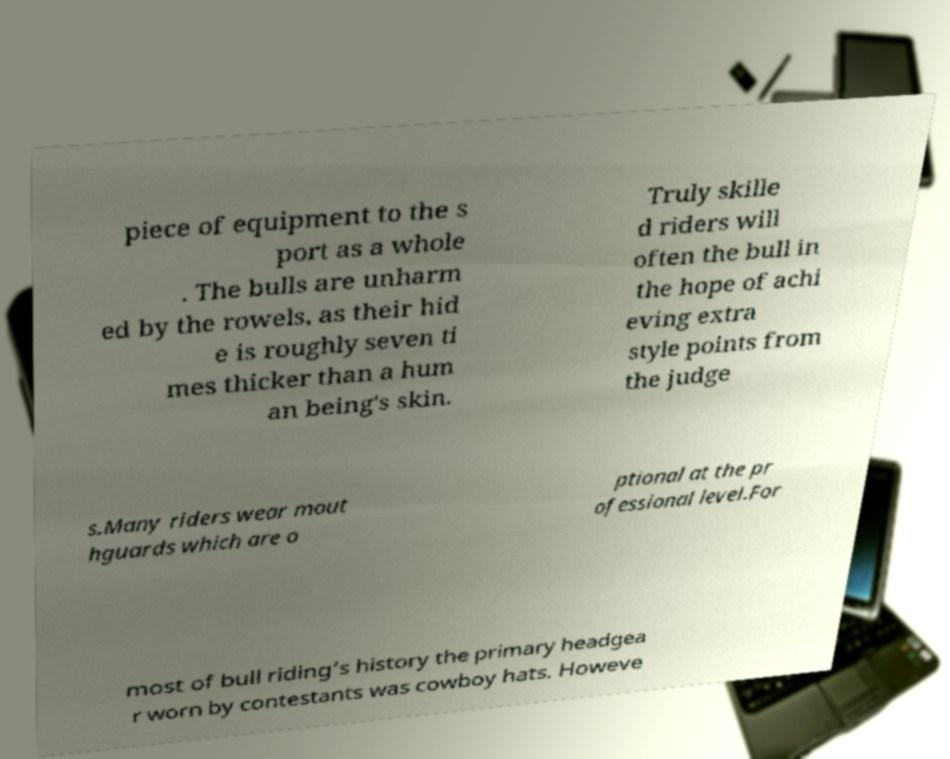I need the written content from this picture converted into text. Can you do that? piece of equipment to the s port as a whole . The bulls are unharm ed by the rowels, as their hid e is roughly seven ti mes thicker than a hum an being's skin. Truly skille d riders will often the bull in the hope of achi eving extra style points from the judge s.Many riders wear mout hguards which are o ptional at the pr ofessional level.For most of bull riding’s history the primary headgea r worn by contestants was cowboy hats. Howeve 